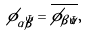Convert formula to latex. <formula><loc_0><loc_0><loc_500><loc_500>\phi _ { \alpha \bar { \beta } } = \overline { \phi _ { \beta \bar { \alpha } } } ,</formula> 